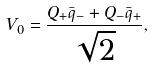<formula> <loc_0><loc_0><loc_500><loc_500>V _ { 0 } = \frac { Q _ { + } \bar { q } _ { - } + Q _ { - } \bar { q } _ { + } } { \sqrt { 2 } } ,</formula> 